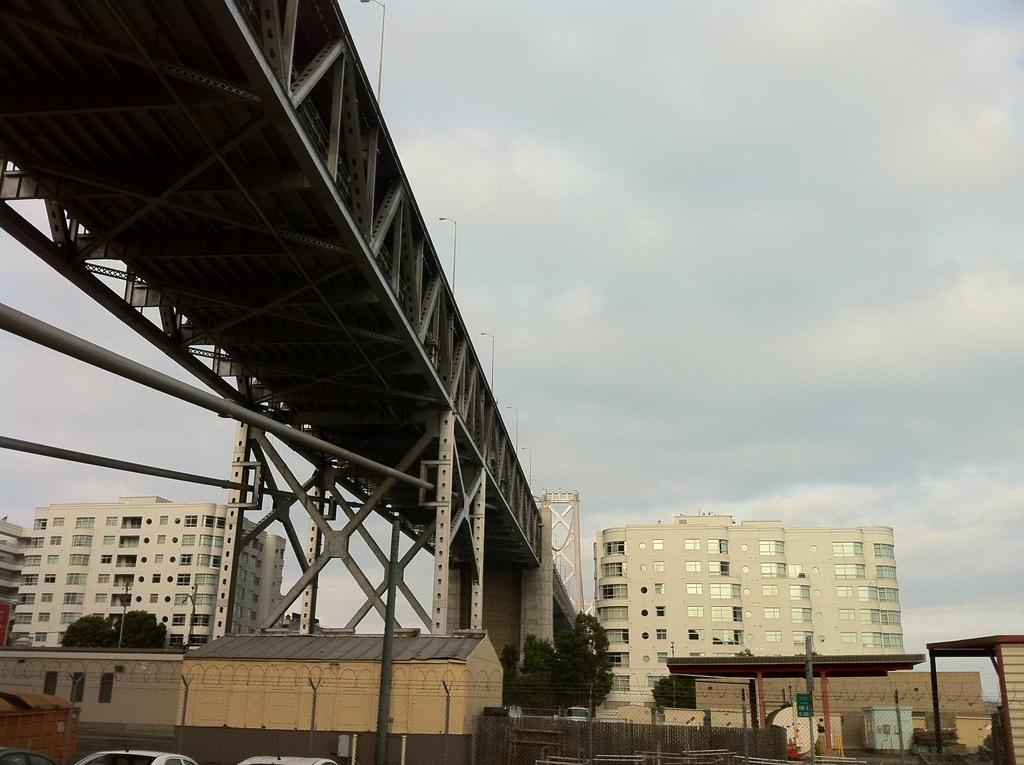What is visible at the top of the image? The sky is visible at the top of the image. What can be seen in the background of the image? There are buildings in the background of the image. Can you describe the green object in the image? There is a green board in the image. What type of vehicles are present at the bottom portion of the image? Cars are present at the bottom portion of the image. How many seeds are planted on the cushion in the image? There is no cushion or seeds present in the image. What type of army is depicted in the image? There is no army depicted in the image; it features a sky, buildings, a green board, and cars. 